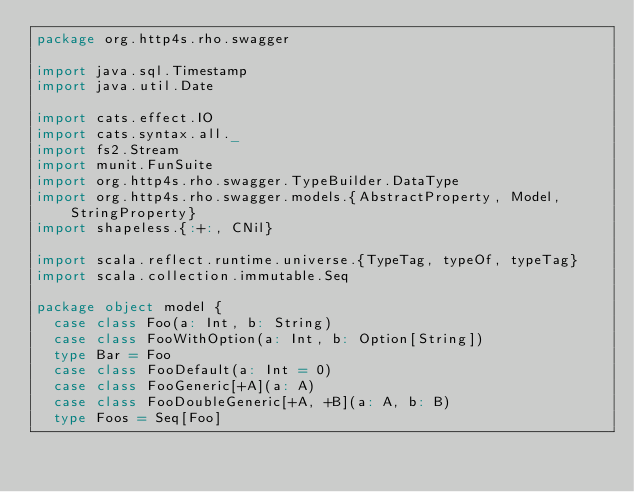Convert code to text. <code><loc_0><loc_0><loc_500><loc_500><_Scala_>package org.http4s.rho.swagger

import java.sql.Timestamp
import java.util.Date

import cats.effect.IO
import cats.syntax.all._
import fs2.Stream
import munit.FunSuite
import org.http4s.rho.swagger.TypeBuilder.DataType
import org.http4s.rho.swagger.models.{AbstractProperty, Model, StringProperty}
import shapeless.{:+:, CNil}

import scala.reflect.runtime.universe.{TypeTag, typeOf, typeTag}
import scala.collection.immutable.Seq

package object model {
  case class Foo(a: Int, b: String)
  case class FooWithOption(a: Int, b: Option[String])
  type Bar = Foo
  case class FooDefault(a: Int = 0)
  case class FooGeneric[+A](a: A)
  case class FooDoubleGeneric[+A, +B](a: A, b: B)
  type Foos = Seq[Foo]</code> 